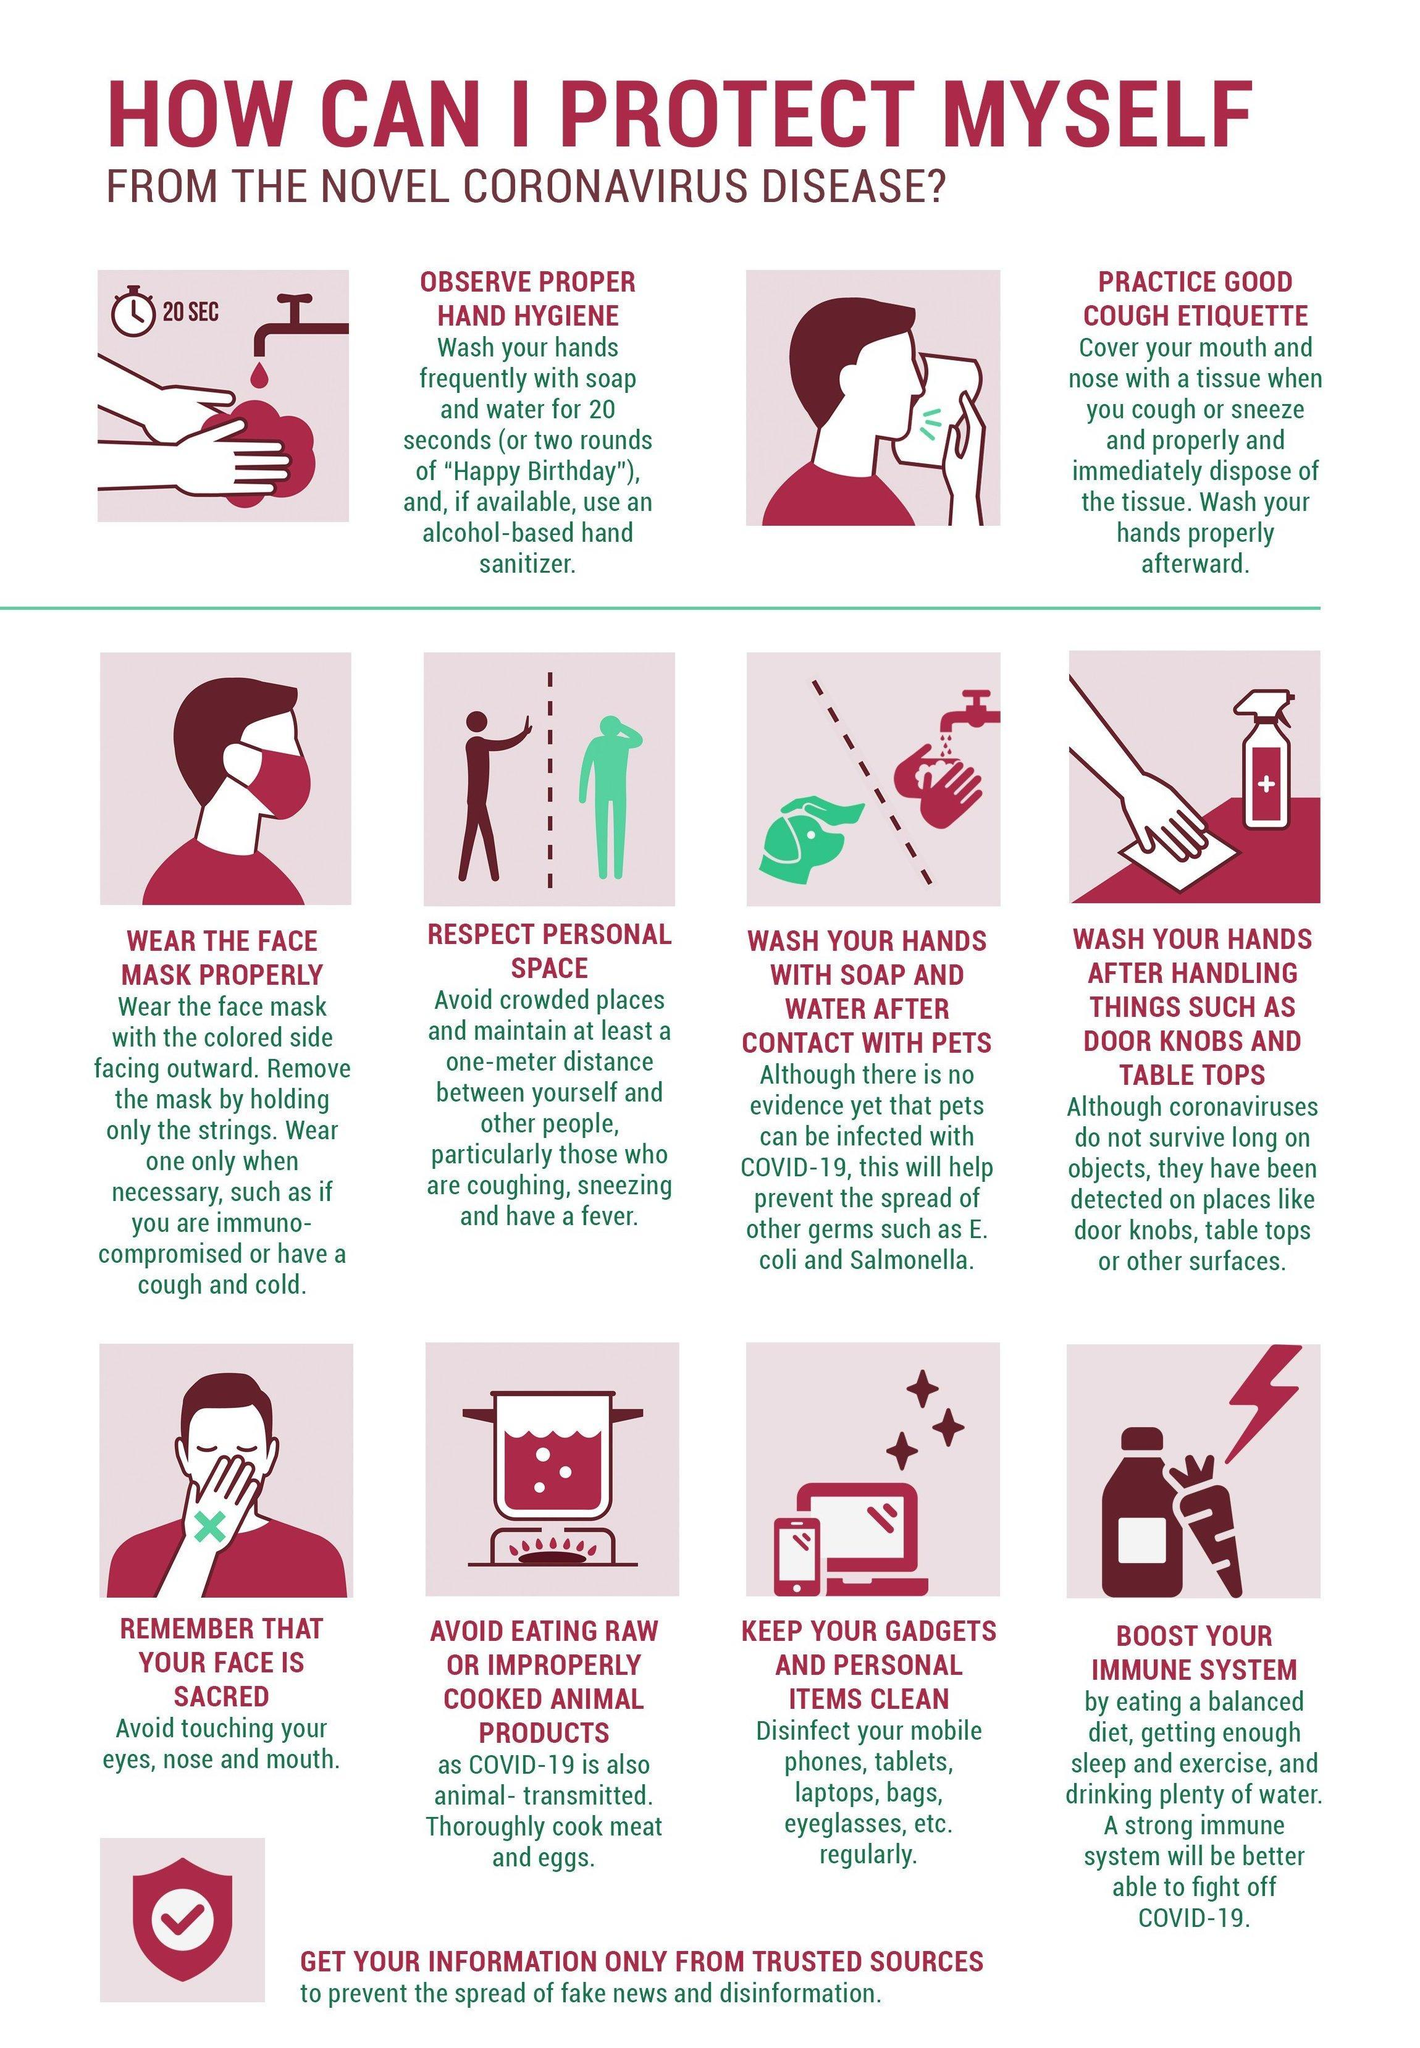How many people are with a mask?
Answer the question with a short phrase. 1 How many gadgets are mentioned in this infographic? 3 How many sanitizers are in this infographic? 1 